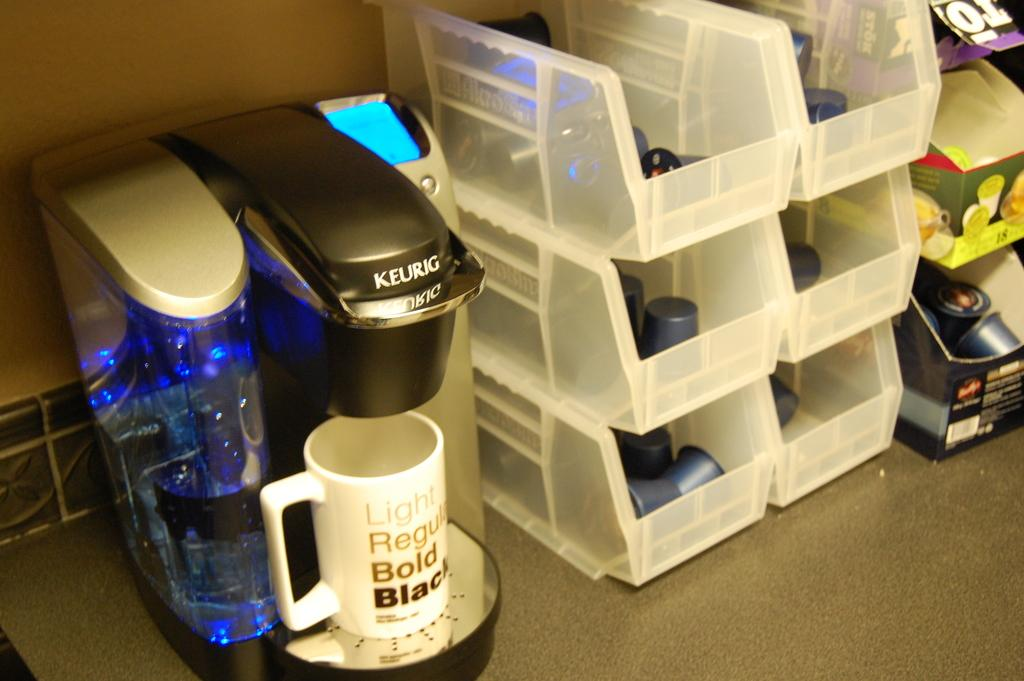<image>
Give a short and clear explanation of the subsequent image. A Keurig coffee maker is filling a mug that says Light Regular Bold Black. 